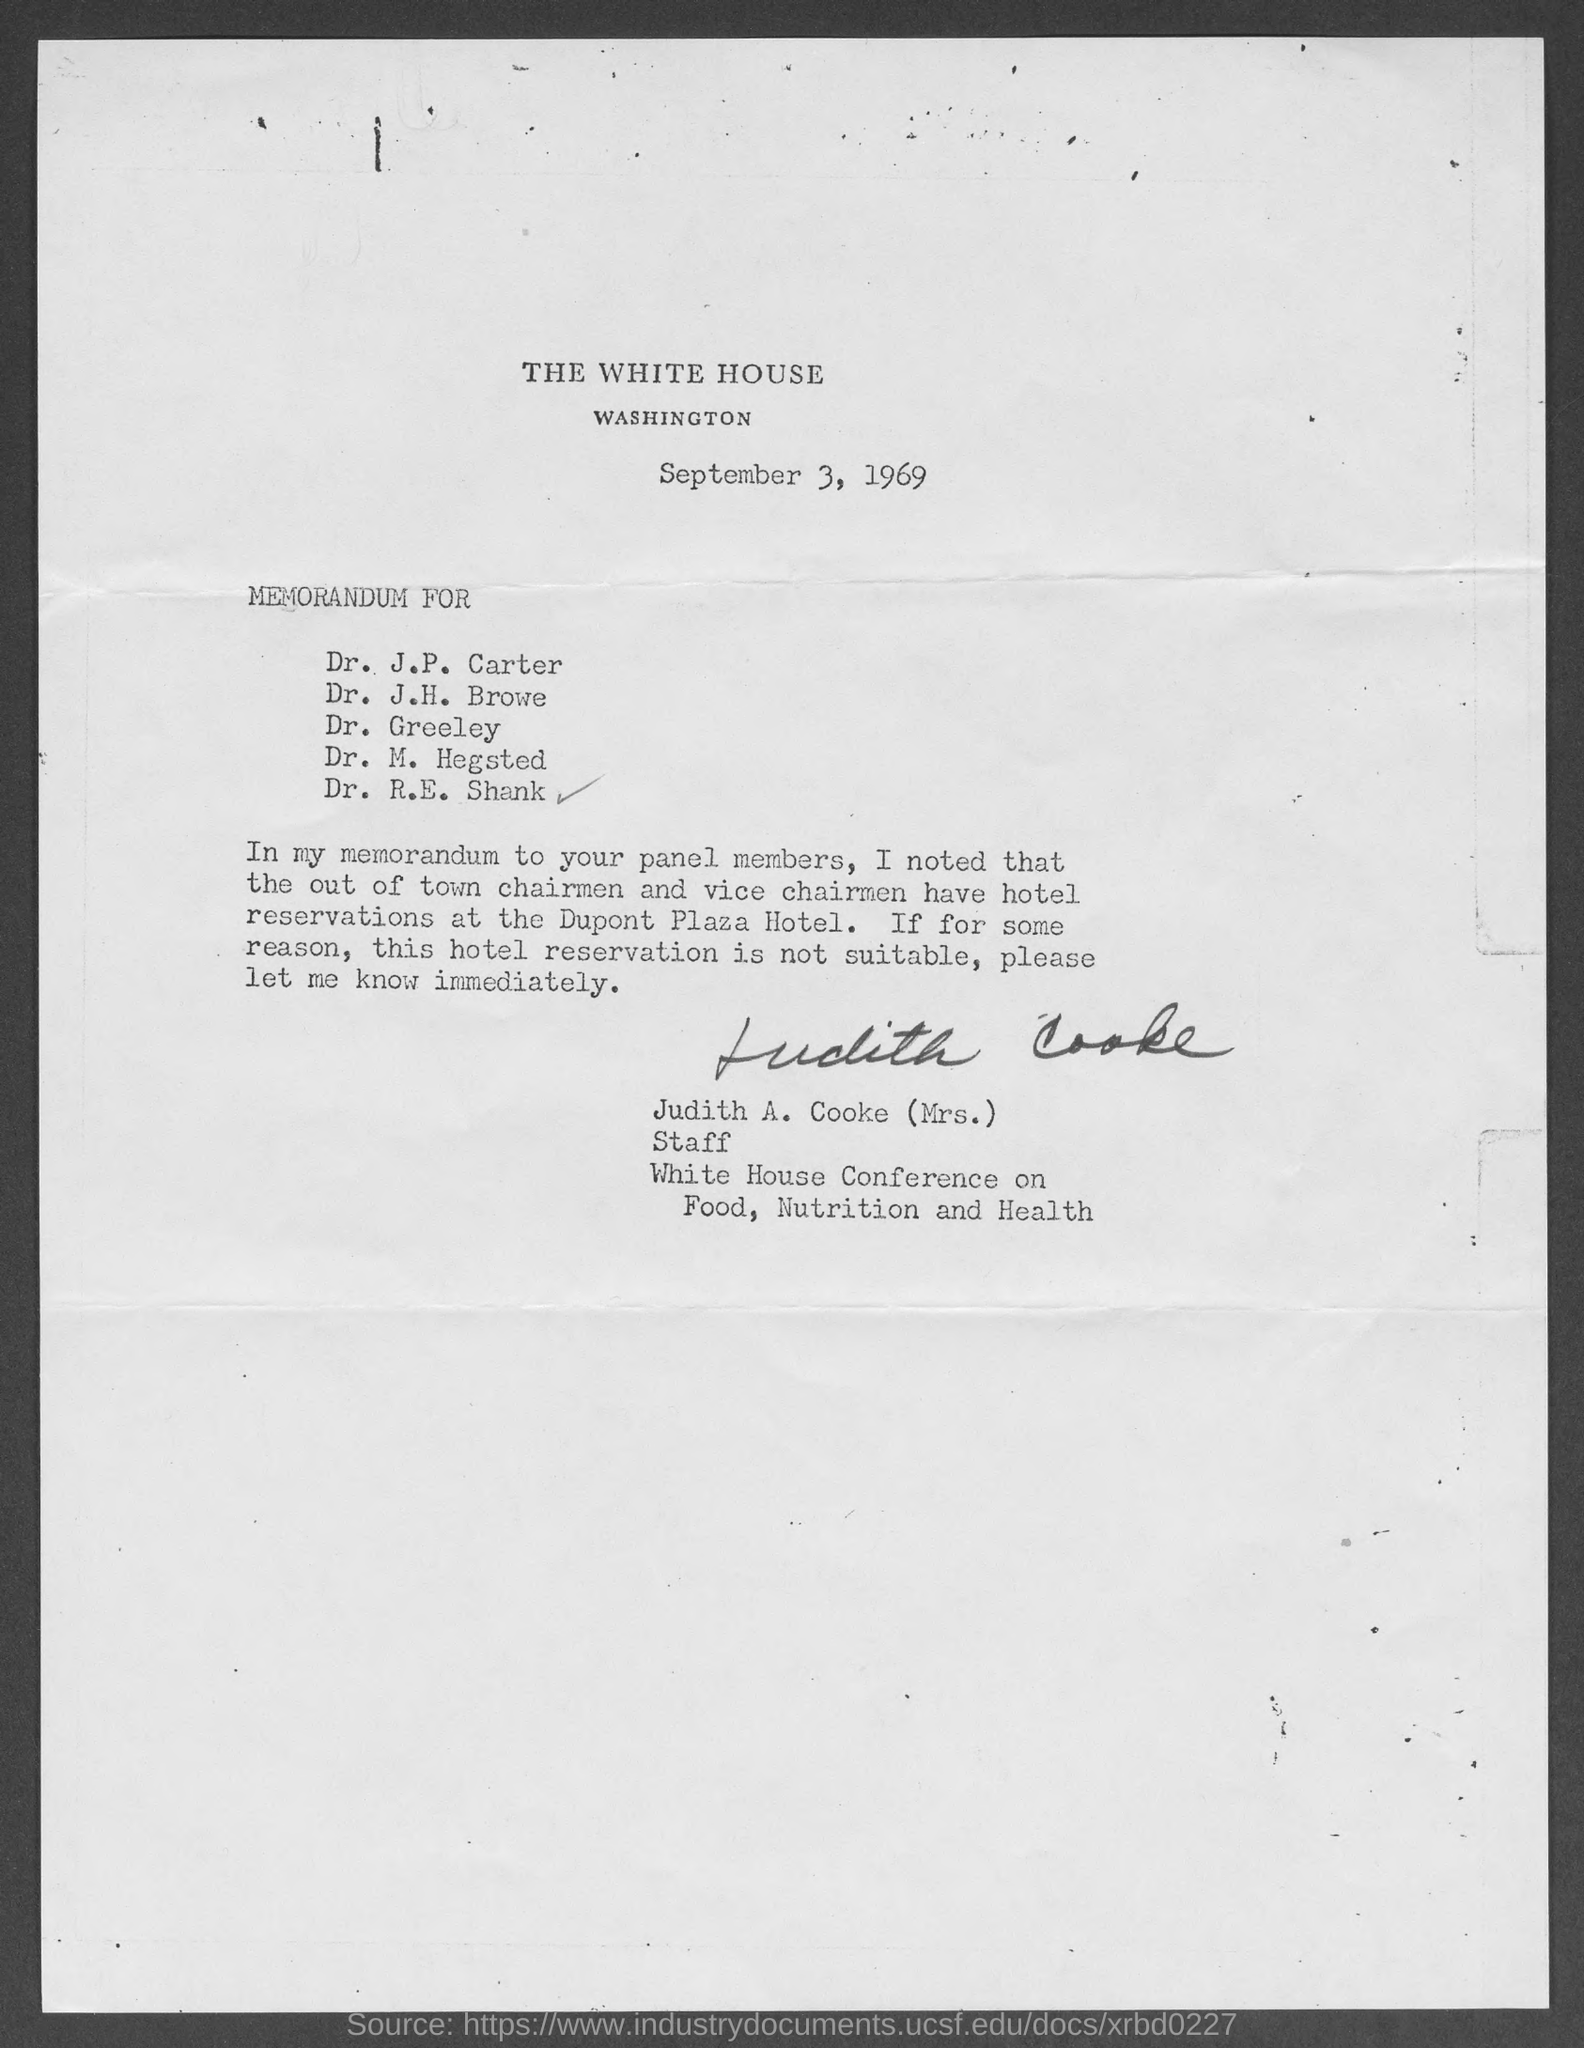Who is the staff, white house conference on food, nutrition and health?
Provide a short and direct response. Judith A. Cooke (Mrs.). 